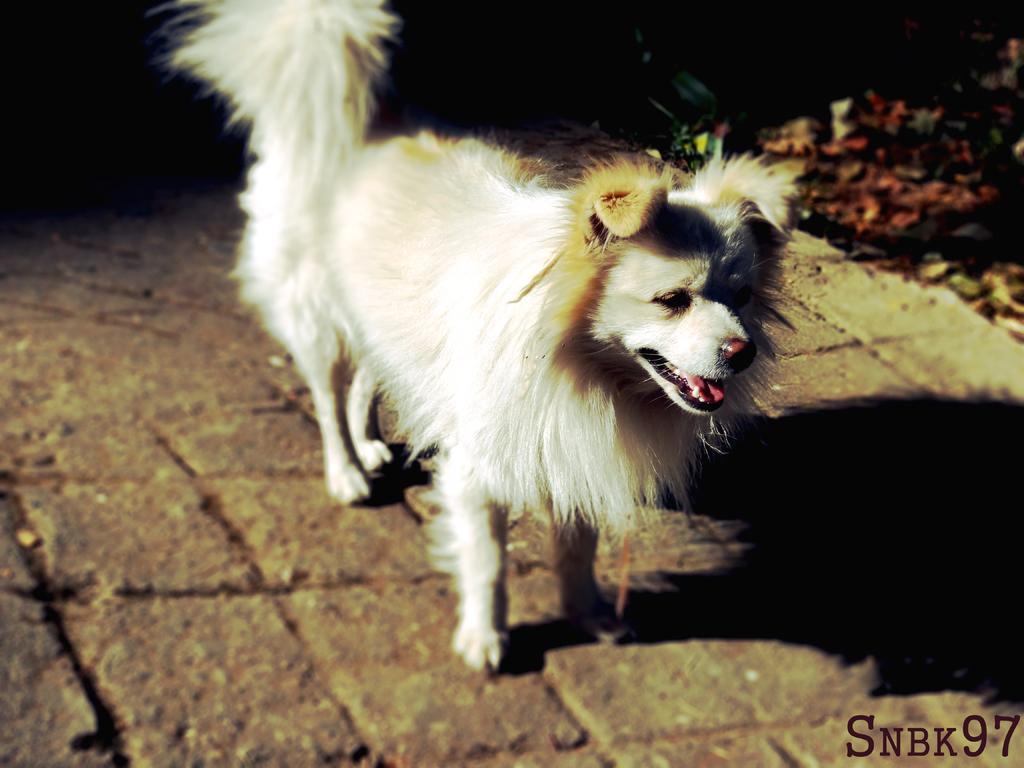How would you summarize this image in a sentence or two? In this image we can see a dog standing on the floor. Beside it there are shredded leaves on the ground. 